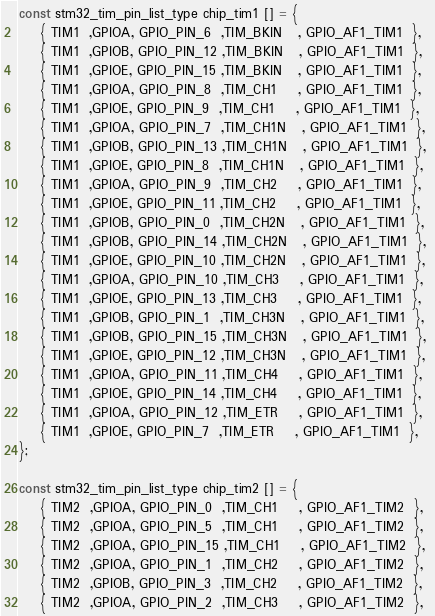<code> <loc_0><loc_0><loc_500><loc_500><_C_>
const stm32_tim_pin_list_type chip_tim1 [] = {
    { TIM1  ,GPIOA, GPIO_PIN_6  ,TIM_BKIN   , GPIO_AF1_TIM1  }, 
    { TIM1  ,GPIOB, GPIO_PIN_12 ,TIM_BKIN   , GPIO_AF1_TIM1  }, 
    { TIM1  ,GPIOE, GPIO_PIN_15 ,TIM_BKIN   , GPIO_AF1_TIM1  }, 
    { TIM1  ,GPIOA, GPIO_PIN_8  ,TIM_CH1    , GPIO_AF1_TIM1  }, 
    { TIM1  ,GPIOE, GPIO_PIN_9  ,TIM_CH1    , GPIO_AF1_TIM1  }, 
    { TIM1  ,GPIOA, GPIO_PIN_7  ,TIM_CH1N   , GPIO_AF1_TIM1  }, 
    { TIM1  ,GPIOB, GPIO_PIN_13 ,TIM_CH1N   , GPIO_AF1_TIM1  }, 
    { TIM1  ,GPIOE, GPIO_PIN_8  ,TIM_CH1N   , GPIO_AF1_TIM1  }, 
    { TIM1  ,GPIOA, GPIO_PIN_9  ,TIM_CH2    , GPIO_AF1_TIM1  }, 
    { TIM1  ,GPIOE, GPIO_PIN_11 ,TIM_CH2    , GPIO_AF1_TIM1  }, 
    { TIM1  ,GPIOB, GPIO_PIN_0  ,TIM_CH2N   , GPIO_AF1_TIM1  }, 
    { TIM1  ,GPIOB, GPIO_PIN_14 ,TIM_CH2N   , GPIO_AF1_TIM1  }, 
    { TIM1  ,GPIOE, GPIO_PIN_10 ,TIM_CH2N   , GPIO_AF1_TIM1  }, 
    { TIM1  ,GPIOA, GPIO_PIN_10 ,TIM_CH3    , GPIO_AF1_TIM1  }, 
    { TIM1  ,GPIOE, GPIO_PIN_13 ,TIM_CH3    , GPIO_AF1_TIM1  }, 
    { TIM1  ,GPIOB, GPIO_PIN_1  ,TIM_CH3N   , GPIO_AF1_TIM1  }, 
    { TIM1  ,GPIOB, GPIO_PIN_15 ,TIM_CH3N   , GPIO_AF1_TIM1  }, 
    { TIM1  ,GPIOE, GPIO_PIN_12 ,TIM_CH3N   , GPIO_AF1_TIM1  }, 
    { TIM1  ,GPIOA, GPIO_PIN_11 ,TIM_CH4    , GPIO_AF1_TIM1  }, 
    { TIM1  ,GPIOE, GPIO_PIN_14 ,TIM_CH4    , GPIO_AF1_TIM1  }, 
    { TIM1  ,GPIOA, GPIO_PIN_12 ,TIM_ETR    , GPIO_AF1_TIM1  }, 
    { TIM1  ,GPIOE, GPIO_PIN_7  ,TIM_ETR    , GPIO_AF1_TIM1  }, 
}; 

const stm32_tim_pin_list_type chip_tim2 [] = {
    { TIM2  ,GPIOA, GPIO_PIN_0  ,TIM_CH1    , GPIO_AF1_TIM2  }, 
    { TIM2  ,GPIOA, GPIO_PIN_5  ,TIM_CH1    , GPIO_AF1_TIM2  }, 
    { TIM2  ,GPIOA, GPIO_PIN_15 ,TIM_CH1    , GPIO_AF1_TIM2  }, 
    { TIM2  ,GPIOA, GPIO_PIN_1  ,TIM_CH2    , GPIO_AF1_TIM2  }, 
    { TIM2  ,GPIOB, GPIO_PIN_3  ,TIM_CH2    , GPIO_AF1_TIM2  }, 
    { TIM2  ,GPIOA, GPIO_PIN_2  ,TIM_CH3    , GPIO_AF1_TIM2  }, </code> 